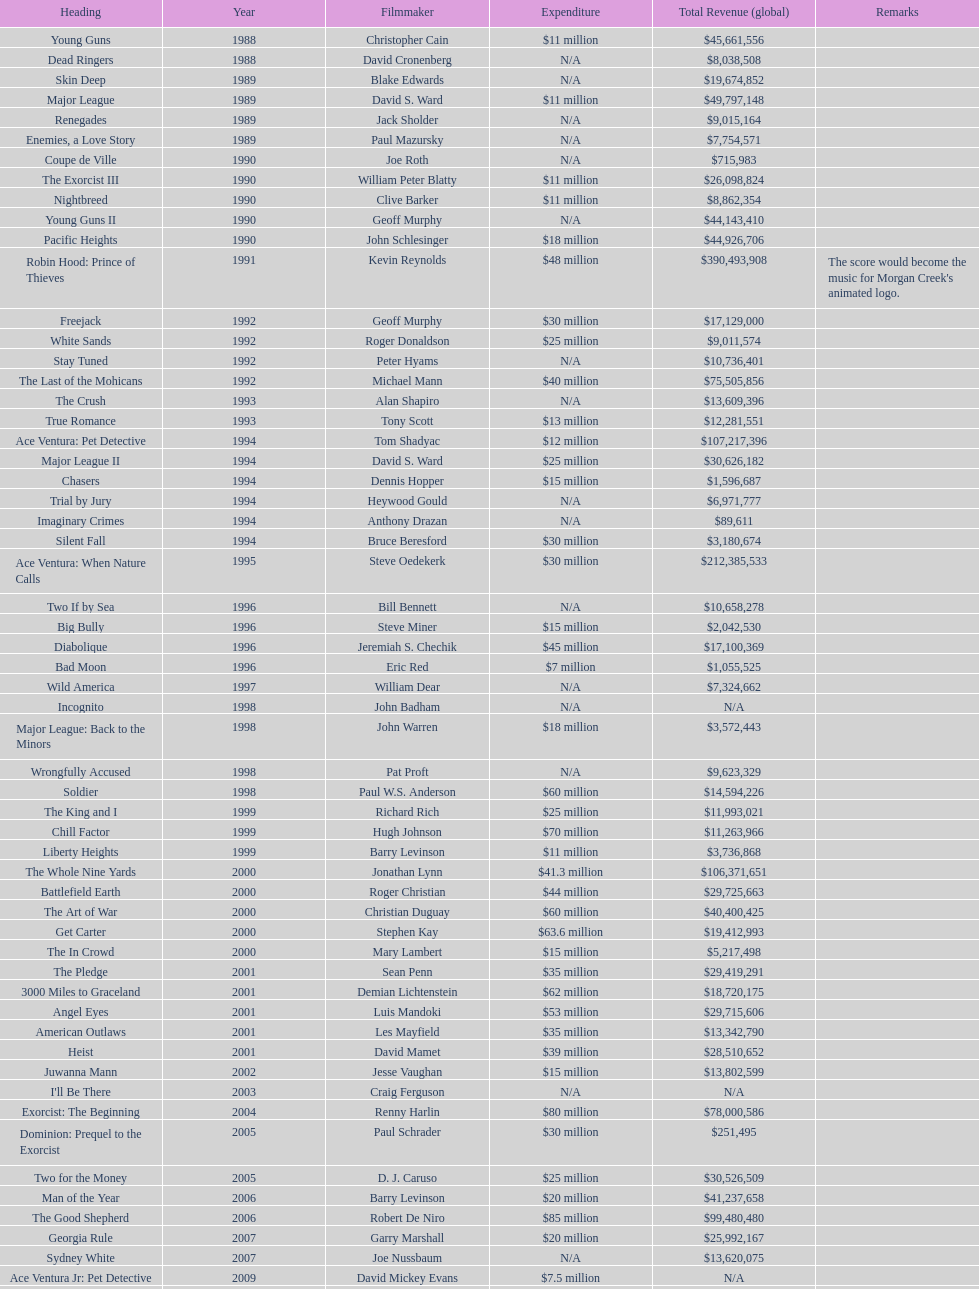Which film had a higher budget, ace ventura: when nature calls, or major league: back to the minors? Ace Ventura: When Nature Calls. 